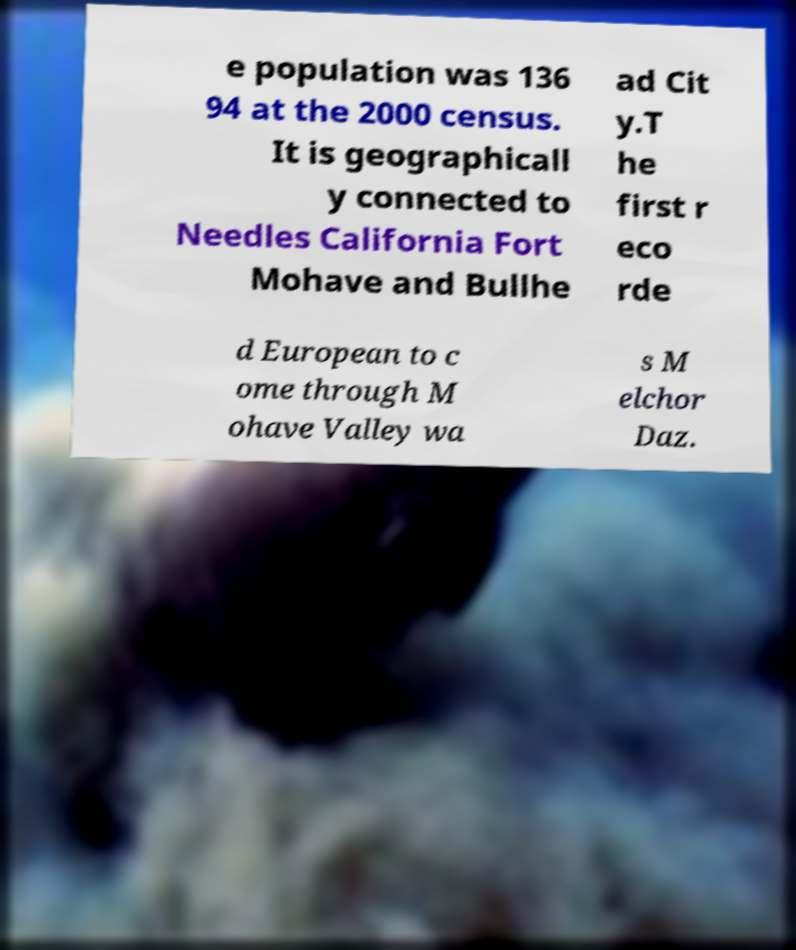Can you accurately transcribe the text from the provided image for me? e population was 136 94 at the 2000 census. It is geographicall y connected to Needles California Fort Mohave and Bullhe ad Cit y.T he first r eco rde d European to c ome through M ohave Valley wa s M elchor Daz. 